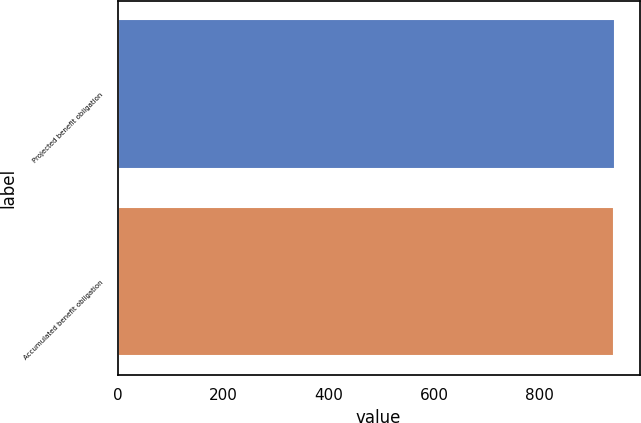Convert chart. <chart><loc_0><loc_0><loc_500><loc_500><bar_chart><fcel>Projected benefit obligation<fcel>Accumulated benefit obligation<nl><fcel>943<fcel>941<nl></chart> 